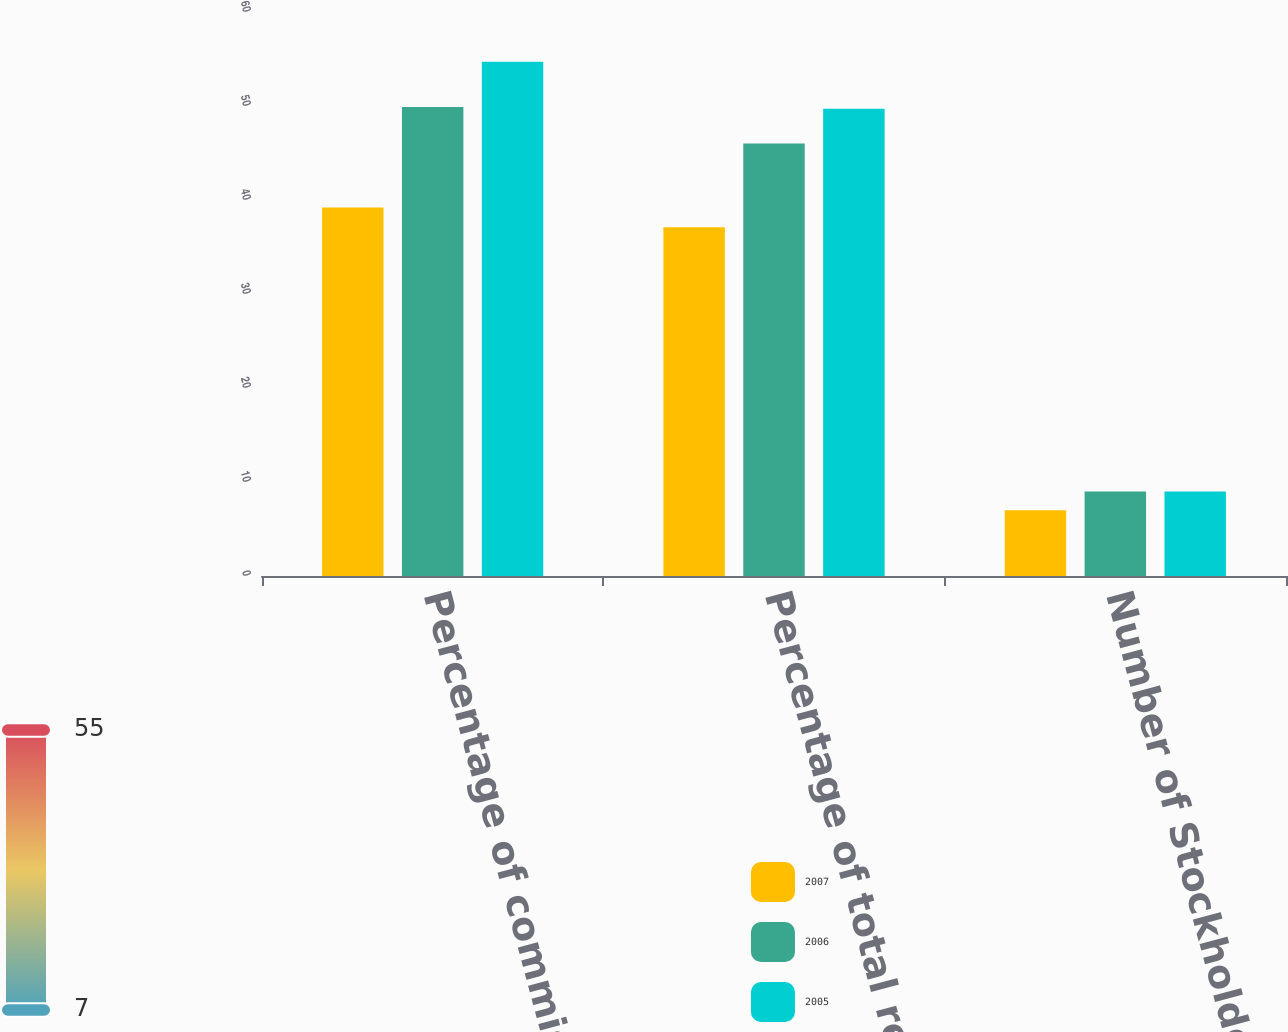<chart> <loc_0><loc_0><loc_500><loc_500><stacked_bar_chart><ecel><fcel>Percentage of commissions<fcel>Percentage of total revenues<fcel>Number of Stockholder<nl><fcel>2007<fcel>39.2<fcel>37.1<fcel>7<nl><fcel>2006<fcel>49.9<fcel>46<fcel>9<nl><fcel>2005<fcel>54.7<fcel>49.7<fcel>9<nl></chart> 